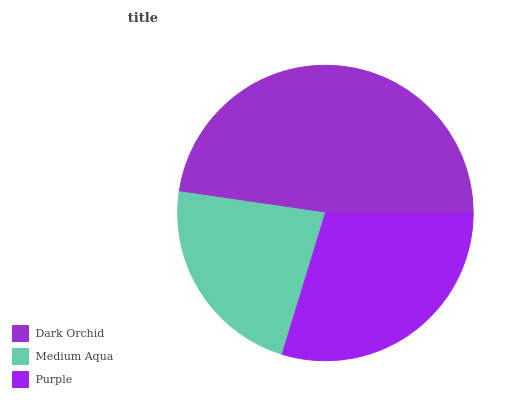Is Medium Aqua the minimum?
Answer yes or no. Yes. Is Dark Orchid the maximum?
Answer yes or no. Yes. Is Purple the minimum?
Answer yes or no. No. Is Purple the maximum?
Answer yes or no. No. Is Purple greater than Medium Aqua?
Answer yes or no. Yes. Is Medium Aqua less than Purple?
Answer yes or no. Yes. Is Medium Aqua greater than Purple?
Answer yes or no. No. Is Purple less than Medium Aqua?
Answer yes or no. No. Is Purple the high median?
Answer yes or no. Yes. Is Purple the low median?
Answer yes or no. Yes. Is Medium Aqua the high median?
Answer yes or no. No. Is Dark Orchid the low median?
Answer yes or no. No. 